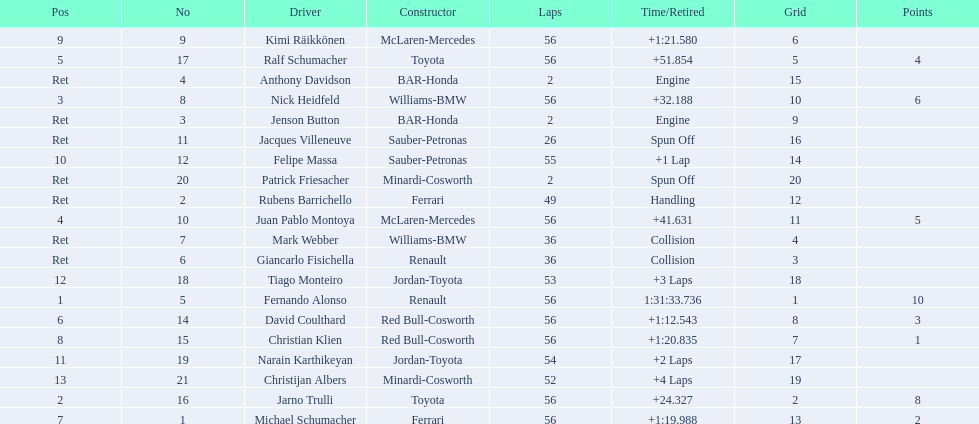How many bmws finished before webber? 1. 